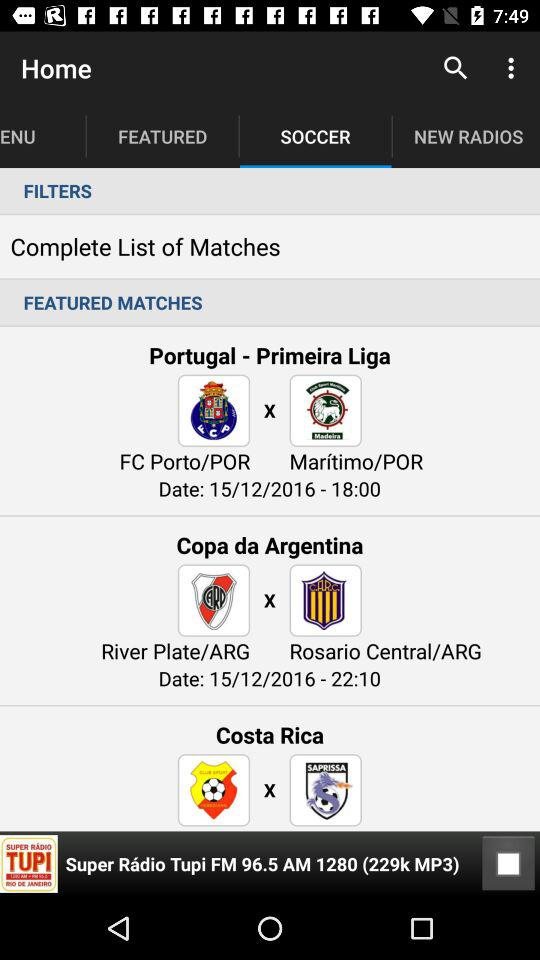Which tab is selected? The selected tab is "SOCCER". 